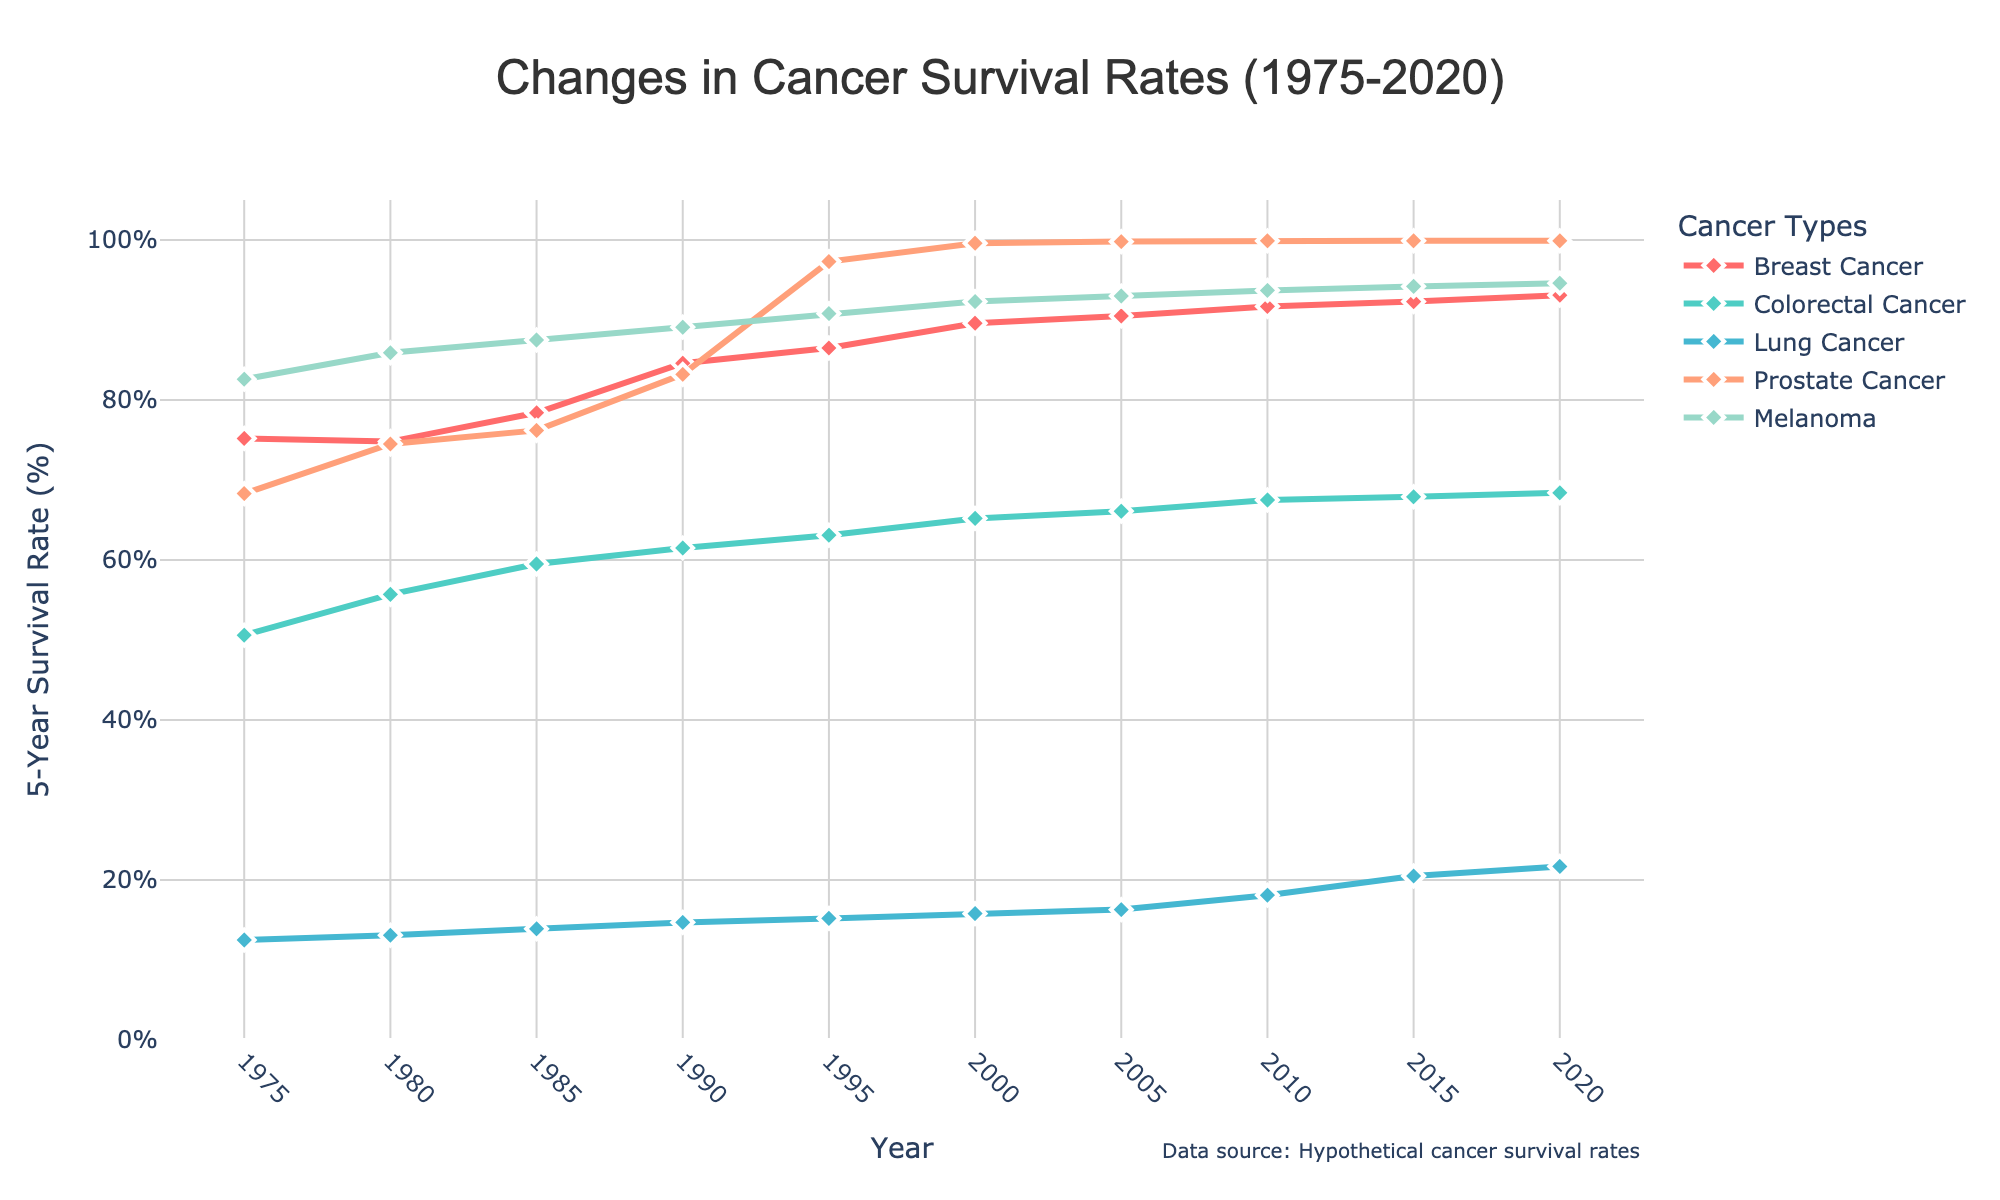What is the trend in breast cancer survival rates from 1975 to 2020? The plot shows a continuous upward trend in breast cancer survival rates from 75.2% in 1975 to 93.1% in 2020.
Answer: Increasing Which type of cancer has shown the least improvement in survival rates from 1975 to 2020? By comparing the survival rates in 1975 and 2020 for each cancer type, lung cancer shows the least improvement, increasing from 12.5% to 21.7%.
Answer: Lung Cancer In which year did prostate cancer survival rates first exceed 90%? By examining the prostate cancer line in the chart, it crossed 90% in 1995 with a survival rate of 97.3%.
Answer: 1995 What is the difference in survival rates between melanoma and lung cancer in 2020? In 2020, melanoma has a survival rate of 94.6%, and lung cancer has 21.7%. The difference is calculated as 94.6% - 21.7% = 72.9%.
Answer: 72.9% How do the trends of colorectal cancer survival rates compare to melanoma survival rates? Colorectal cancer survival rates show a gradual increase from 50.6% in 1975 to 68.4% in 2020. In contrast, melanoma starts higher at 82.6% in 1975 and climbs to 94.6% in 2020, showing both cancers have an upward trend but melanoma has higher survival rates overall.
Answer: Both increasing, melanoma higher Which type of cancer had the highest survival rate in 2005? By observing the 2005 data points, melanoma had the highest survival rate at 93%.
Answer: Melanoma What is the average survival rate of breast cancer over the entire period (1975-2020)? Sum the survival rates of breast cancer for each year: 75.2 + 74.8 + 78.4 + 84.6 + 86.5 + 89.6 + 90.5 + 91.7 + 92.3 + 93.1 = 856.7. Divide by the number of data points (10): 856.7 / 10 = 85.67%.
Answer: 85.67% Compare the rate of improvement in survival rates between lung cancer and breast cancer from 1975 to 2020. For breast cancer, the rate improved from 75.2% to 93.1%, a difference of 17.9%. For lung cancer, it improved from 12.5% to 21.7%, a difference of 9.2%. Hence, breast cancer's improvement is greater.
Answer: Breast cancer's improvement is greater Which type of cancer had the steepest increase in survival rates between two consecutive points, and during which years did this occur? By analyzing the steepness of the lines between points, prostate cancer had the steepest increase between 1990 and 1995, jumping from 83.2% to 97.3%, an increase of 14.1%.
Answer: Prostate cancer, between 1990 and 1995 In 1985, was the survival rate for melanoma closer to the rate for breast cancer or prostate cancer? In 1985, melanoma's survival rate was 87.5%. Breast cancer was 78.4% and prostate cancer was 76.2%. The difference is 87.5%-78.4%=9.1% for breast cancer and 87.5%-76.2%=11.3% for prostate cancer, showing melanoma was closer to breast cancer.
Answer: Breast cancer 